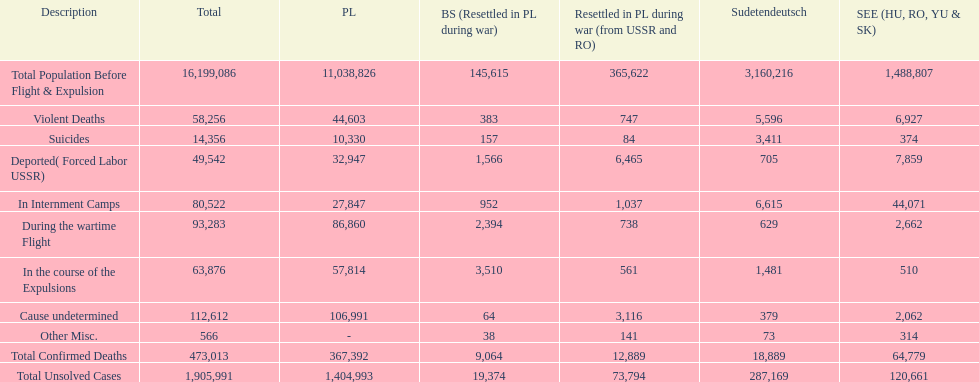What is the cumulative death toll in internment camps and amid the wartime flight? 173,805. 